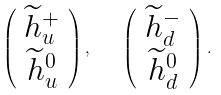Convert formula to latex. <formula><loc_0><loc_0><loc_500><loc_500>\left ( \begin{array} { c } { { \widetilde { h } _ { u } ^ { + } } } \\ { { \widetilde { h } _ { u } ^ { 0 } } } \end{array} \right ) , \quad \left ( \begin{array} { c } { { \widetilde { h } _ { d } ^ { - } } } \\ { { \widetilde { h } _ { d } ^ { 0 } } } \end{array} \right ) .</formula> 